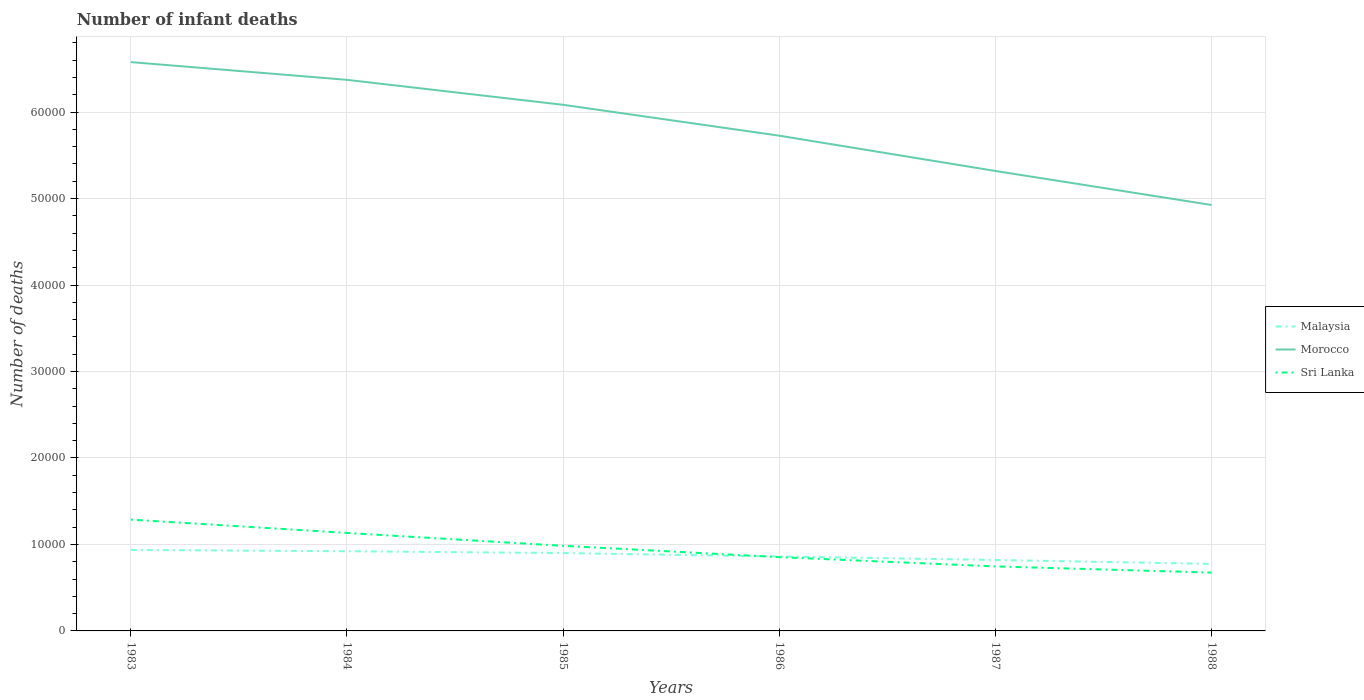Does the line corresponding to Morocco intersect with the line corresponding to Sri Lanka?
Provide a short and direct response. No. Is the number of lines equal to the number of legend labels?
Provide a succinct answer. Yes. Across all years, what is the maximum number of infant deaths in Morocco?
Ensure brevity in your answer.  4.93e+04. What is the total number of infant deaths in Malaysia in the graph?
Your answer should be very brief. 209. What is the difference between the highest and the second highest number of infant deaths in Sri Lanka?
Offer a terse response. 6122. What is the difference between the highest and the lowest number of infant deaths in Malaysia?
Provide a short and direct response. 3. Is the number of infant deaths in Sri Lanka strictly greater than the number of infant deaths in Morocco over the years?
Ensure brevity in your answer.  Yes. What is the difference between two consecutive major ticks on the Y-axis?
Offer a terse response. 10000. Are the values on the major ticks of Y-axis written in scientific E-notation?
Your answer should be compact. No. Does the graph contain grids?
Make the answer very short. Yes. Where does the legend appear in the graph?
Give a very brief answer. Center right. How many legend labels are there?
Offer a terse response. 3. How are the legend labels stacked?
Your response must be concise. Vertical. What is the title of the graph?
Provide a succinct answer. Number of infant deaths. Does "North America" appear as one of the legend labels in the graph?
Offer a very short reply. No. What is the label or title of the Y-axis?
Offer a very short reply. Number of deaths. What is the Number of deaths of Malaysia in 1983?
Your answer should be very brief. 9364. What is the Number of deaths of Morocco in 1983?
Your answer should be very brief. 6.58e+04. What is the Number of deaths of Sri Lanka in 1983?
Make the answer very short. 1.29e+04. What is the Number of deaths in Malaysia in 1984?
Your response must be concise. 9215. What is the Number of deaths of Morocco in 1984?
Provide a short and direct response. 6.37e+04. What is the Number of deaths in Sri Lanka in 1984?
Offer a terse response. 1.13e+04. What is the Number of deaths in Malaysia in 1985?
Your response must be concise. 9006. What is the Number of deaths of Morocco in 1985?
Provide a short and direct response. 6.08e+04. What is the Number of deaths of Sri Lanka in 1985?
Make the answer very short. 9841. What is the Number of deaths of Malaysia in 1986?
Your answer should be compact. 8607. What is the Number of deaths of Morocco in 1986?
Your response must be concise. 5.73e+04. What is the Number of deaths in Sri Lanka in 1986?
Provide a short and direct response. 8533. What is the Number of deaths of Malaysia in 1987?
Your response must be concise. 8204. What is the Number of deaths of Morocco in 1987?
Provide a short and direct response. 5.32e+04. What is the Number of deaths in Sri Lanka in 1987?
Ensure brevity in your answer.  7461. What is the Number of deaths of Malaysia in 1988?
Ensure brevity in your answer.  7753. What is the Number of deaths in Morocco in 1988?
Offer a very short reply. 4.93e+04. What is the Number of deaths of Sri Lanka in 1988?
Offer a terse response. 6747. Across all years, what is the maximum Number of deaths of Malaysia?
Provide a succinct answer. 9364. Across all years, what is the maximum Number of deaths of Morocco?
Offer a terse response. 6.58e+04. Across all years, what is the maximum Number of deaths in Sri Lanka?
Offer a terse response. 1.29e+04. Across all years, what is the minimum Number of deaths of Malaysia?
Provide a short and direct response. 7753. Across all years, what is the minimum Number of deaths in Morocco?
Your response must be concise. 4.93e+04. Across all years, what is the minimum Number of deaths in Sri Lanka?
Make the answer very short. 6747. What is the total Number of deaths of Malaysia in the graph?
Your answer should be very brief. 5.21e+04. What is the total Number of deaths in Morocco in the graph?
Offer a very short reply. 3.50e+05. What is the total Number of deaths in Sri Lanka in the graph?
Provide a succinct answer. 5.68e+04. What is the difference between the Number of deaths of Malaysia in 1983 and that in 1984?
Your answer should be compact. 149. What is the difference between the Number of deaths of Morocco in 1983 and that in 1984?
Ensure brevity in your answer.  2051. What is the difference between the Number of deaths in Sri Lanka in 1983 and that in 1984?
Your answer should be compact. 1536. What is the difference between the Number of deaths in Malaysia in 1983 and that in 1985?
Your answer should be very brief. 358. What is the difference between the Number of deaths of Morocco in 1983 and that in 1985?
Offer a very short reply. 4938. What is the difference between the Number of deaths in Sri Lanka in 1983 and that in 1985?
Ensure brevity in your answer.  3028. What is the difference between the Number of deaths of Malaysia in 1983 and that in 1986?
Provide a succinct answer. 757. What is the difference between the Number of deaths of Morocco in 1983 and that in 1986?
Provide a succinct answer. 8509. What is the difference between the Number of deaths in Sri Lanka in 1983 and that in 1986?
Your answer should be very brief. 4336. What is the difference between the Number of deaths in Malaysia in 1983 and that in 1987?
Provide a succinct answer. 1160. What is the difference between the Number of deaths in Morocco in 1983 and that in 1987?
Make the answer very short. 1.26e+04. What is the difference between the Number of deaths in Sri Lanka in 1983 and that in 1987?
Ensure brevity in your answer.  5408. What is the difference between the Number of deaths of Malaysia in 1983 and that in 1988?
Your answer should be very brief. 1611. What is the difference between the Number of deaths in Morocco in 1983 and that in 1988?
Your answer should be compact. 1.65e+04. What is the difference between the Number of deaths in Sri Lanka in 1983 and that in 1988?
Keep it short and to the point. 6122. What is the difference between the Number of deaths in Malaysia in 1984 and that in 1985?
Your answer should be compact. 209. What is the difference between the Number of deaths in Morocco in 1984 and that in 1985?
Offer a very short reply. 2887. What is the difference between the Number of deaths of Sri Lanka in 1984 and that in 1985?
Provide a short and direct response. 1492. What is the difference between the Number of deaths in Malaysia in 1984 and that in 1986?
Ensure brevity in your answer.  608. What is the difference between the Number of deaths in Morocco in 1984 and that in 1986?
Ensure brevity in your answer.  6458. What is the difference between the Number of deaths of Sri Lanka in 1984 and that in 1986?
Provide a succinct answer. 2800. What is the difference between the Number of deaths in Malaysia in 1984 and that in 1987?
Provide a succinct answer. 1011. What is the difference between the Number of deaths of Morocco in 1984 and that in 1987?
Make the answer very short. 1.05e+04. What is the difference between the Number of deaths of Sri Lanka in 1984 and that in 1987?
Keep it short and to the point. 3872. What is the difference between the Number of deaths in Malaysia in 1984 and that in 1988?
Give a very brief answer. 1462. What is the difference between the Number of deaths in Morocco in 1984 and that in 1988?
Provide a succinct answer. 1.45e+04. What is the difference between the Number of deaths in Sri Lanka in 1984 and that in 1988?
Ensure brevity in your answer.  4586. What is the difference between the Number of deaths in Malaysia in 1985 and that in 1986?
Your answer should be compact. 399. What is the difference between the Number of deaths of Morocco in 1985 and that in 1986?
Give a very brief answer. 3571. What is the difference between the Number of deaths in Sri Lanka in 1985 and that in 1986?
Give a very brief answer. 1308. What is the difference between the Number of deaths of Malaysia in 1985 and that in 1987?
Your response must be concise. 802. What is the difference between the Number of deaths of Morocco in 1985 and that in 1987?
Provide a succinct answer. 7651. What is the difference between the Number of deaths in Sri Lanka in 1985 and that in 1987?
Your answer should be very brief. 2380. What is the difference between the Number of deaths of Malaysia in 1985 and that in 1988?
Your response must be concise. 1253. What is the difference between the Number of deaths of Morocco in 1985 and that in 1988?
Provide a succinct answer. 1.16e+04. What is the difference between the Number of deaths in Sri Lanka in 1985 and that in 1988?
Your response must be concise. 3094. What is the difference between the Number of deaths in Malaysia in 1986 and that in 1987?
Give a very brief answer. 403. What is the difference between the Number of deaths of Morocco in 1986 and that in 1987?
Give a very brief answer. 4080. What is the difference between the Number of deaths of Sri Lanka in 1986 and that in 1987?
Ensure brevity in your answer.  1072. What is the difference between the Number of deaths of Malaysia in 1986 and that in 1988?
Offer a very short reply. 854. What is the difference between the Number of deaths of Morocco in 1986 and that in 1988?
Provide a short and direct response. 8014. What is the difference between the Number of deaths of Sri Lanka in 1986 and that in 1988?
Provide a succinct answer. 1786. What is the difference between the Number of deaths of Malaysia in 1987 and that in 1988?
Offer a very short reply. 451. What is the difference between the Number of deaths in Morocco in 1987 and that in 1988?
Your response must be concise. 3934. What is the difference between the Number of deaths of Sri Lanka in 1987 and that in 1988?
Make the answer very short. 714. What is the difference between the Number of deaths of Malaysia in 1983 and the Number of deaths of Morocco in 1984?
Your answer should be compact. -5.44e+04. What is the difference between the Number of deaths of Malaysia in 1983 and the Number of deaths of Sri Lanka in 1984?
Provide a short and direct response. -1969. What is the difference between the Number of deaths in Morocco in 1983 and the Number of deaths in Sri Lanka in 1984?
Provide a short and direct response. 5.44e+04. What is the difference between the Number of deaths of Malaysia in 1983 and the Number of deaths of Morocco in 1985?
Give a very brief answer. -5.15e+04. What is the difference between the Number of deaths in Malaysia in 1983 and the Number of deaths in Sri Lanka in 1985?
Give a very brief answer. -477. What is the difference between the Number of deaths of Morocco in 1983 and the Number of deaths of Sri Lanka in 1985?
Your answer should be compact. 5.59e+04. What is the difference between the Number of deaths in Malaysia in 1983 and the Number of deaths in Morocco in 1986?
Give a very brief answer. -4.79e+04. What is the difference between the Number of deaths of Malaysia in 1983 and the Number of deaths of Sri Lanka in 1986?
Your answer should be very brief. 831. What is the difference between the Number of deaths in Morocco in 1983 and the Number of deaths in Sri Lanka in 1986?
Your answer should be very brief. 5.72e+04. What is the difference between the Number of deaths of Malaysia in 1983 and the Number of deaths of Morocco in 1987?
Your answer should be very brief. -4.38e+04. What is the difference between the Number of deaths in Malaysia in 1983 and the Number of deaths in Sri Lanka in 1987?
Your response must be concise. 1903. What is the difference between the Number of deaths in Morocco in 1983 and the Number of deaths in Sri Lanka in 1987?
Keep it short and to the point. 5.83e+04. What is the difference between the Number of deaths of Malaysia in 1983 and the Number of deaths of Morocco in 1988?
Give a very brief answer. -3.99e+04. What is the difference between the Number of deaths of Malaysia in 1983 and the Number of deaths of Sri Lanka in 1988?
Offer a very short reply. 2617. What is the difference between the Number of deaths in Morocco in 1983 and the Number of deaths in Sri Lanka in 1988?
Keep it short and to the point. 5.90e+04. What is the difference between the Number of deaths in Malaysia in 1984 and the Number of deaths in Morocco in 1985?
Your answer should be very brief. -5.16e+04. What is the difference between the Number of deaths of Malaysia in 1984 and the Number of deaths of Sri Lanka in 1985?
Ensure brevity in your answer.  -626. What is the difference between the Number of deaths in Morocco in 1984 and the Number of deaths in Sri Lanka in 1985?
Your response must be concise. 5.39e+04. What is the difference between the Number of deaths in Malaysia in 1984 and the Number of deaths in Morocco in 1986?
Keep it short and to the point. -4.81e+04. What is the difference between the Number of deaths in Malaysia in 1984 and the Number of deaths in Sri Lanka in 1986?
Offer a terse response. 682. What is the difference between the Number of deaths in Morocco in 1984 and the Number of deaths in Sri Lanka in 1986?
Offer a terse response. 5.52e+04. What is the difference between the Number of deaths in Malaysia in 1984 and the Number of deaths in Morocco in 1987?
Provide a succinct answer. -4.40e+04. What is the difference between the Number of deaths in Malaysia in 1984 and the Number of deaths in Sri Lanka in 1987?
Give a very brief answer. 1754. What is the difference between the Number of deaths of Morocco in 1984 and the Number of deaths of Sri Lanka in 1987?
Your answer should be compact. 5.63e+04. What is the difference between the Number of deaths in Malaysia in 1984 and the Number of deaths in Morocco in 1988?
Offer a very short reply. -4.00e+04. What is the difference between the Number of deaths of Malaysia in 1984 and the Number of deaths of Sri Lanka in 1988?
Your response must be concise. 2468. What is the difference between the Number of deaths in Morocco in 1984 and the Number of deaths in Sri Lanka in 1988?
Your response must be concise. 5.70e+04. What is the difference between the Number of deaths of Malaysia in 1985 and the Number of deaths of Morocco in 1986?
Keep it short and to the point. -4.83e+04. What is the difference between the Number of deaths in Malaysia in 1985 and the Number of deaths in Sri Lanka in 1986?
Provide a short and direct response. 473. What is the difference between the Number of deaths of Morocco in 1985 and the Number of deaths of Sri Lanka in 1986?
Make the answer very short. 5.23e+04. What is the difference between the Number of deaths of Malaysia in 1985 and the Number of deaths of Morocco in 1987?
Keep it short and to the point. -4.42e+04. What is the difference between the Number of deaths in Malaysia in 1985 and the Number of deaths in Sri Lanka in 1987?
Provide a short and direct response. 1545. What is the difference between the Number of deaths in Morocco in 1985 and the Number of deaths in Sri Lanka in 1987?
Make the answer very short. 5.34e+04. What is the difference between the Number of deaths in Malaysia in 1985 and the Number of deaths in Morocco in 1988?
Your answer should be compact. -4.02e+04. What is the difference between the Number of deaths of Malaysia in 1985 and the Number of deaths of Sri Lanka in 1988?
Keep it short and to the point. 2259. What is the difference between the Number of deaths in Morocco in 1985 and the Number of deaths in Sri Lanka in 1988?
Offer a very short reply. 5.41e+04. What is the difference between the Number of deaths in Malaysia in 1986 and the Number of deaths in Morocco in 1987?
Make the answer very short. -4.46e+04. What is the difference between the Number of deaths in Malaysia in 1986 and the Number of deaths in Sri Lanka in 1987?
Keep it short and to the point. 1146. What is the difference between the Number of deaths of Morocco in 1986 and the Number of deaths of Sri Lanka in 1987?
Offer a very short reply. 4.98e+04. What is the difference between the Number of deaths in Malaysia in 1986 and the Number of deaths in Morocco in 1988?
Your answer should be compact. -4.06e+04. What is the difference between the Number of deaths in Malaysia in 1986 and the Number of deaths in Sri Lanka in 1988?
Offer a terse response. 1860. What is the difference between the Number of deaths in Morocco in 1986 and the Number of deaths in Sri Lanka in 1988?
Your answer should be very brief. 5.05e+04. What is the difference between the Number of deaths of Malaysia in 1987 and the Number of deaths of Morocco in 1988?
Keep it short and to the point. -4.11e+04. What is the difference between the Number of deaths of Malaysia in 1987 and the Number of deaths of Sri Lanka in 1988?
Your response must be concise. 1457. What is the difference between the Number of deaths in Morocco in 1987 and the Number of deaths in Sri Lanka in 1988?
Offer a very short reply. 4.64e+04. What is the average Number of deaths of Malaysia per year?
Your response must be concise. 8691.5. What is the average Number of deaths of Morocco per year?
Provide a succinct answer. 5.83e+04. What is the average Number of deaths in Sri Lanka per year?
Your answer should be compact. 9464. In the year 1983, what is the difference between the Number of deaths of Malaysia and Number of deaths of Morocco?
Keep it short and to the point. -5.64e+04. In the year 1983, what is the difference between the Number of deaths of Malaysia and Number of deaths of Sri Lanka?
Offer a very short reply. -3505. In the year 1983, what is the difference between the Number of deaths in Morocco and Number of deaths in Sri Lanka?
Give a very brief answer. 5.29e+04. In the year 1984, what is the difference between the Number of deaths of Malaysia and Number of deaths of Morocco?
Offer a terse response. -5.45e+04. In the year 1984, what is the difference between the Number of deaths of Malaysia and Number of deaths of Sri Lanka?
Provide a short and direct response. -2118. In the year 1984, what is the difference between the Number of deaths in Morocco and Number of deaths in Sri Lanka?
Provide a short and direct response. 5.24e+04. In the year 1985, what is the difference between the Number of deaths of Malaysia and Number of deaths of Morocco?
Offer a very short reply. -5.18e+04. In the year 1985, what is the difference between the Number of deaths in Malaysia and Number of deaths in Sri Lanka?
Ensure brevity in your answer.  -835. In the year 1985, what is the difference between the Number of deaths of Morocco and Number of deaths of Sri Lanka?
Your answer should be very brief. 5.10e+04. In the year 1986, what is the difference between the Number of deaths in Malaysia and Number of deaths in Morocco?
Keep it short and to the point. -4.87e+04. In the year 1986, what is the difference between the Number of deaths in Morocco and Number of deaths in Sri Lanka?
Provide a short and direct response. 4.87e+04. In the year 1987, what is the difference between the Number of deaths in Malaysia and Number of deaths in Morocco?
Provide a succinct answer. -4.50e+04. In the year 1987, what is the difference between the Number of deaths in Malaysia and Number of deaths in Sri Lanka?
Your answer should be compact. 743. In the year 1987, what is the difference between the Number of deaths in Morocco and Number of deaths in Sri Lanka?
Keep it short and to the point. 4.57e+04. In the year 1988, what is the difference between the Number of deaths in Malaysia and Number of deaths in Morocco?
Your answer should be compact. -4.15e+04. In the year 1988, what is the difference between the Number of deaths of Malaysia and Number of deaths of Sri Lanka?
Offer a very short reply. 1006. In the year 1988, what is the difference between the Number of deaths in Morocco and Number of deaths in Sri Lanka?
Your answer should be very brief. 4.25e+04. What is the ratio of the Number of deaths of Malaysia in 1983 to that in 1984?
Offer a very short reply. 1.02. What is the ratio of the Number of deaths of Morocco in 1983 to that in 1984?
Your answer should be compact. 1.03. What is the ratio of the Number of deaths of Sri Lanka in 1983 to that in 1984?
Ensure brevity in your answer.  1.14. What is the ratio of the Number of deaths in Malaysia in 1983 to that in 1985?
Your answer should be compact. 1.04. What is the ratio of the Number of deaths in Morocco in 1983 to that in 1985?
Provide a succinct answer. 1.08. What is the ratio of the Number of deaths in Sri Lanka in 1983 to that in 1985?
Make the answer very short. 1.31. What is the ratio of the Number of deaths of Malaysia in 1983 to that in 1986?
Offer a terse response. 1.09. What is the ratio of the Number of deaths in Morocco in 1983 to that in 1986?
Provide a succinct answer. 1.15. What is the ratio of the Number of deaths of Sri Lanka in 1983 to that in 1986?
Your answer should be very brief. 1.51. What is the ratio of the Number of deaths of Malaysia in 1983 to that in 1987?
Your response must be concise. 1.14. What is the ratio of the Number of deaths in Morocco in 1983 to that in 1987?
Your answer should be very brief. 1.24. What is the ratio of the Number of deaths in Sri Lanka in 1983 to that in 1987?
Keep it short and to the point. 1.72. What is the ratio of the Number of deaths of Malaysia in 1983 to that in 1988?
Your response must be concise. 1.21. What is the ratio of the Number of deaths in Morocco in 1983 to that in 1988?
Give a very brief answer. 1.34. What is the ratio of the Number of deaths of Sri Lanka in 1983 to that in 1988?
Give a very brief answer. 1.91. What is the ratio of the Number of deaths of Malaysia in 1984 to that in 1985?
Ensure brevity in your answer.  1.02. What is the ratio of the Number of deaths in Morocco in 1984 to that in 1985?
Your answer should be very brief. 1.05. What is the ratio of the Number of deaths of Sri Lanka in 1984 to that in 1985?
Offer a very short reply. 1.15. What is the ratio of the Number of deaths in Malaysia in 1984 to that in 1986?
Offer a terse response. 1.07. What is the ratio of the Number of deaths of Morocco in 1984 to that in 1986?
Keep it short and to the point. 1.11. What is the ratio of the Number of deaths of Sri Lanka in 1984 to that in 1986?
Provide a succinct answer. 1.33. What is the ratio of the Number of deaths of Malaysia in 1984 to that in 1987?
Your response must be concise. 1.12. What is the ratio of the Number of deaths in Morocco in 1984 to that in 1987?
Offer a very short reply. 1.2. What is the ratio of the Number of deaths in Sri Lanka in 1984 to that in 1987?
Your response must be concise. 1.52. What is the ratio of the Number of deaths in Malaysia in 1984 to that in 1988?
Offer a very short reply. 1.19. What is the ratio of the Number of deaths in Morocco in 1984 to that in 1988?
Give a very brief answer. 1.29. What is the ratio of the Number of deaths of Sri Lanka in 1984 to that in 1988?
Your answer should be very brief. 1.68. What is the ratio of the Number of deaths of Malaysia in 1985 to that in 1986?
Give a very brief answer. 1.05. What is the ratio of the Number of deaths in Morocco in 1985 to that in 1986?
Make the answer very short. 1.06. What is the ratio of the Number of deaths in Sri Lanka in 1985 to that in 1986?
Offer a terse response. 1.15. What is the ratio of the Number of deaths in Malaysia in 1985 to that in 1987?
Your answer should be very brief. 1.1. What is the ratio of the Number of deaths of Morocco in 1985 to that in 1987?
Make the answer very short. 1.14. What is the ratio of the Number of deaths in Sri Lanka in 1985 to that in 1987?
Make the answer very short. 1.32. What is the ratio of the Number of deaths of Malaysia in 1985 to that in 1988?
Your response must be concise. 1.16. What is the ratio of the Number of deaths of Morocco in 1985 to that in 1988?
Make the answer very short. 1.24. What is the ratio of the Number of deaths in Sri Lanka in 1985 to that in 1988?
Your answer should be compact. 1.46. What is the ratio of the Number of deaths in Malaysia in 1986 to that in 1987?
Keep it short and to the point. 1.05. What is the ratio of the Number of deaths in Morocco in 1986 to that in 1987?
Ensure brevity in your answer.  1.08. What is the ratio of the Number of deaths in Sri Lanka in 1986 to that in 1987?
Provide a short and direct response. 1.14. What is the ratio of the Number of deaths in Malaysia in 1986 to that in 1988?
Keep it short and to the point. 1.11. What is the ratio of the Number of deaths of Morocco in 1986 to that in 1988?
Provide a succinct answer. 1.16. What is the ratio of the Number of deaths of Sri Lanka in 1986 to that in 1988?
Give a very brief answer. 1.26. What is the ratio of the Number of deaths of Malaysia in 1987 to that in 1988?
Your answer should be compact. 1.06. What is the ratio of the Number of deaths in Morocco in 1987 to that in 1988?
Provide a short and direct response. 1.08. What is the ratio of the Number of deaths in Sri Lanka in 1987 to that in 1988?
Your answer should be very brief. 1.11. What is the difference between the highest and the second highest Number of deaths in Malaysia?
Ensure brevity in your answer.  149. What is the difference between the highest and the second highest Number of deaths of Morocco?
Provide a short and direct response. 2051. What is the difference between the highest and the second highest Number of deaths of Sri Lanka?
Give a very brief answer. 1536. What is the difference between the highest and the lowest Number of deaths in Malaysia?
Provide a succinct answer. 1611. What is the difference between the highest and the lowest Number of deaths in Morocco?
Give a very brief answer. 1.65e+04. What is the difference between the highest and the lowest Number of deaths in Sri Lanka?
Provide a short and direct response. 6122. 